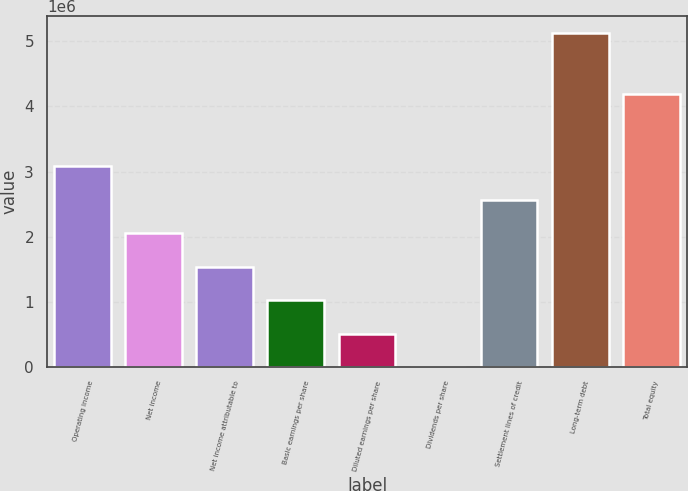<chart> <loc_0><loc_0><loc_500><loc_500><bar_chart><fcel>Operating income<fcel>Net income<fcel>Net income attributable to<fcel>Basic earnings per share<fcel>Diluted earnings per share<fcel>Dividends per share<fcel>Settlement lines of credit<fcel>Long-term debt<fcel>Total equity<nl><fcel>3.07815e+06<fcel>2.0521e+06<fcel>1.53907e+06<fcel>1.02605e+06<fcel>513024<fcel>0.04<fcel>2.56512e+06<fcel>5.13024e+06<fcel>4.18634e+06<nl></chart> 